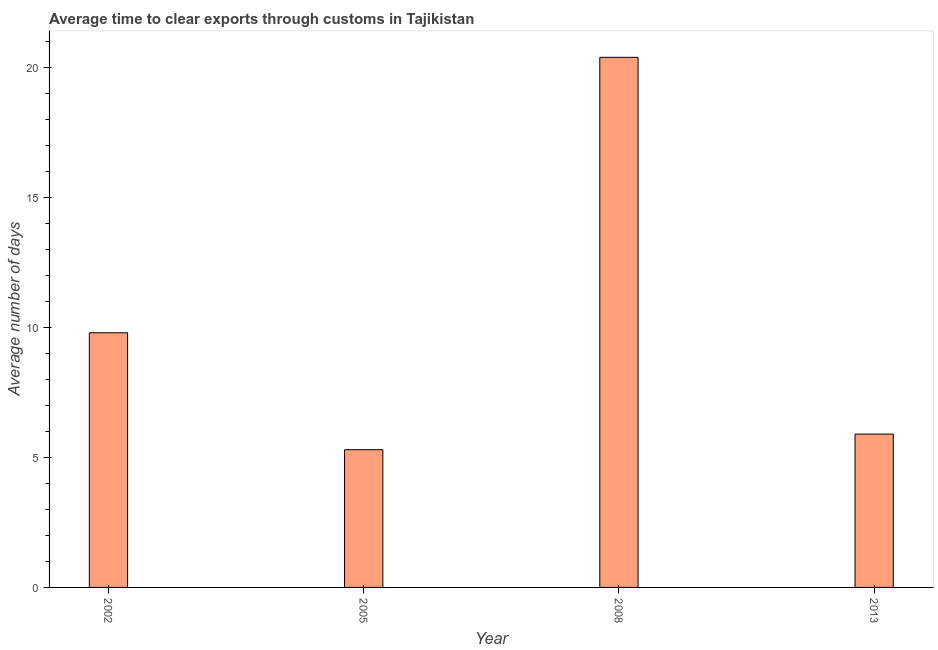Does the graph contain any zero values?
Offer a terse response. No. Does the graph contain grids?
Your answer should be very brief. No. What is the title of the graph?
Offer a very short reply. Average time to clear exports through customs in Tajikistan. What is the label or title of the X-axis?
Keep it short and to the point. Year. What is the label or title of the Y-axis?
Offer a terse response. Average number of days. Across all years, what is the maximum time to clear exports through customs?
Offer a terse response. 20.4. Across all years, what is the minimum time to clear exports through customs?
Your answer should be very brief. 5.3. In which year was the time to clear exports through customs maximum?
Your answer should be very brief. 2008. What is the sum of the time to clear exports through customs?
Your answer should be very brief. 41.4. What is the difference between the time to clear exports through customs in 2005 and 2008?
Your answer should be very brief. -15.1. What is the average time to clear exports through customs per year?
Make the answer very short. 10.35. What is the median time to clear exports through customs?
Offer a very short reply. 7.85. In how many years, is the time to clear exports through customs greater than 3 days?
Give a very brief answer. 4. Do a majority of the years between 2008 and 2005 (inclusive) have time to clear exports through customs greater than 3 days?
Give a very brief answer. No. What is the ratio of the time to clear exports through customs in 2002 to that in 2013?
Give a very brief answer. 1.66. Is the difference between the time to clear exports through customs in 2005 and 2008 greater than the difference between any two years?
Offer a very short reply. Yes. What is the difference between the highest and the lowest time to clear exports through customs?
Your response must be concise. 15.1. How many years are there in the graph?
Your answer should be compact. 4. What is the Average number of days of 2005?
Your response must be concise. 5.3. What is the Average number of days in 2008?
Offer a very short reply. 20.4. What is the difference between the Average number of days in 2002 and 2005?
Provide a short and direct response. 4.5. What is the difference between the Average number of days in 2005 and 2008?
Provide a succinct answer. -15.1. What is the difference between the Average number of days in 2008 and 2013?
Keep it short and to the point. 14.5. What is the ratio of the Average number of days in 2002 to that in 2005?
Provide a succinct answer. 1.85. What is the ratio of the Average number of days in 2002 to that in 2008?
Keep it short and to the point. 0.48. What is the ratio of the Average number of days in 2002 to that in 2013?
Offer a terse response. 1.66. What is the ratio of the Average number of days in 2005 to that in 2008?
Provide a short and direct response. 0.26. What is the ratio of the Average number of days in 2005 to that in 2013?
Provide a short and direct response. 0.9. What is the ratio of the Average number of days in 2008 to that in 2013?
Offer a terse response. 3.46. 